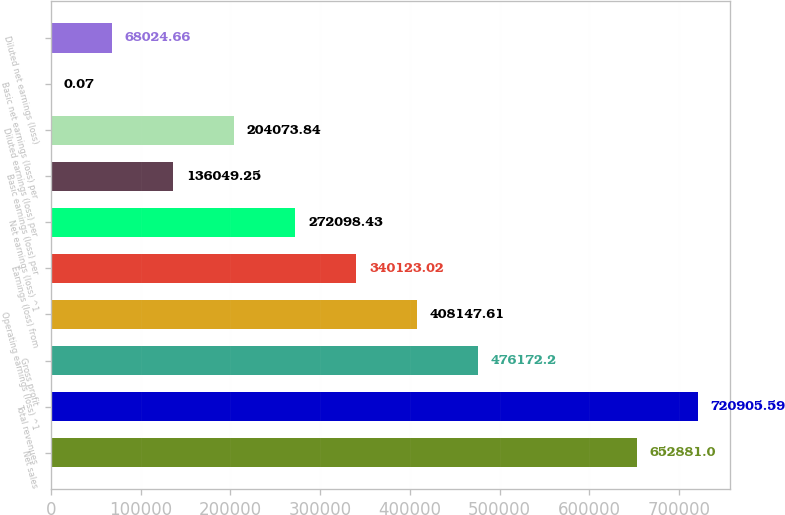Convert chart. <chart><loc_0><loc_0><loc_500><loc_500><bar_chart><fcel>Net sales<fcel>Total revenues<fcel>Gross profit<fcel>Operating earnings (loss) ^1<fcel>Earnings (loss) from<fcel>Net earnings (loss) ^1<fcel>Basic earnings (loss) per<fcel>Diluted earnings (loss) per<fcel>Basic net earnings (loss) per<fcel>Diluted net earnings (loss)<nl><fcel>652881<fcel>720906<fcel>476172<fcel>408148<fcel>340123<fcel>272098<fcel>136049<fcel>204074<fcel>0.07<fcel>68024.7<nl></chart> 